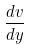<formula> <loc_0><loc_0><loc_500><loc_500>\frac { d v } { d y }</formula> 